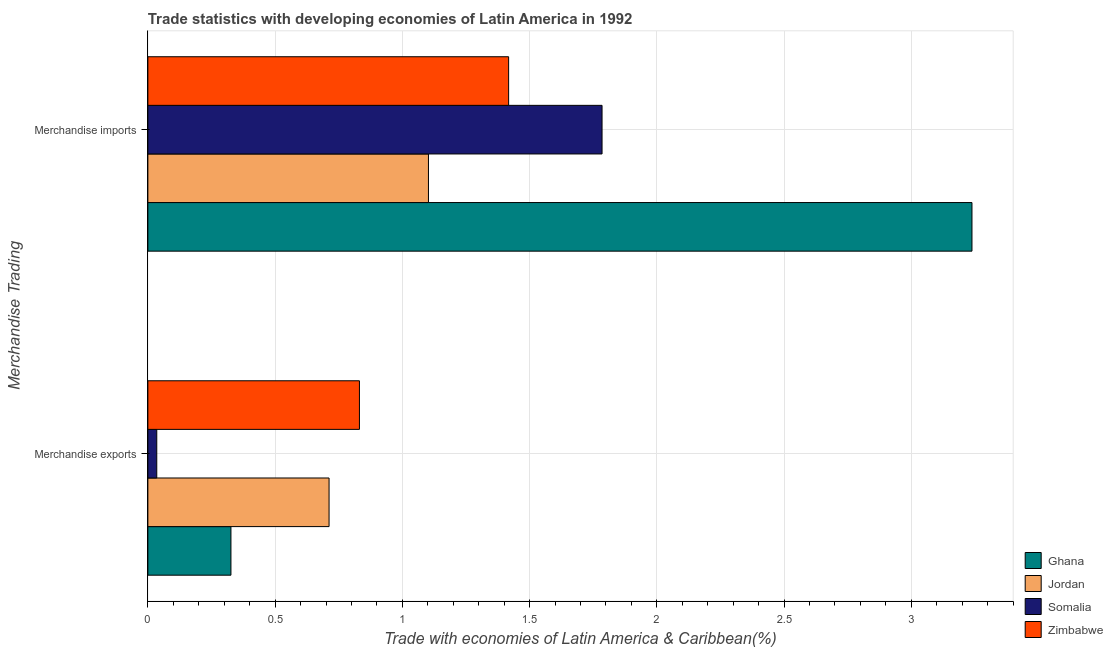Are the number of bars on each tick of the Y-axis equal?
Make the answer very short. Yes. What is the merchandise exports in Jordan?
Give a very brief answer. 0.71. Across all countries, what is the maximum merchandise imports?
Your answer should be very brief. 3.24. Across all countries, what is the minimum merchandise exports?
Your answer should be compact. 0.03. In which country was the merchandise exports minimum?
Provide a short and direct response. Somalia. What is the total merchandise imports in the graph?
Ensure brevity in your answer.  7.54. What is the difference between the merchandise imports in Zimbabwe and that in Ghana?
Provide a succinct answer. -1.82. What is the difference between the merchandise imports in Somalia and the merchandise exports in Ghana?
Your answer should be very brief. 1.46. What is the average merchandise imports per country?
Give a very brief answer. 1.89. What is the difference between the merchandise imports and merchandise exports in Jordan?
Give a very brief answer. 0.39. What is the ratio of the merchandise imports in Jordan to that in Zimbabwe?
Your answer should be very brief. 0.78. Is the merchandise imports in Zimbabwe less than that in Somalia?
Your answer should be very brief. Yes. In how many countries, is the merchandise imports greater than the average merchandise imports taken over all countries?
Make the answer very short. 1. What does the 2nd bar from the top in Merchandise imports represents?
Give a very brief answer. Somalia. What does the 3rd bar from the bottom in Merchandise exports represents?
Your response must be concise. Somalia. How many bars are there?
Provide a succinct answer. 8. How many countries are there in the graph?
Your response must be concise. 4. What is the difference between two consecutive major ticks on the X-axis?
Keep it short and to the point. 0.5. Does the graph contain any zero values?
Give a very brief answer. No. How many legend labels are there?
Make the answer very short. 4. What is the title of the graph?
Your response must be concise. Trade statistics with developing economies of Latin America in 1992. Does "Barbados" appear as one of the legend labels in the graph?
Your answer should be compact. No. What is the label or title of the X-axis?
Make the answer very short. Trade with economies of Latin America & Caribbean(%). What is the label or title of the Y-axis?
Your response must be concise. Merchandise Trading. What is the Trade with economies of Latin America & Caribbean(%) of Ghana in Merchandise exports?
Your answer should be compact. 0.33. What is the Trade with economies of Latin America & Caribbean(%) in Jordan in Merchandise exports?
Provide a succinct answer. 0.71. What is the Trade with economies of Latin America & Caribbean(%) in Somalia in Merchandise exports?
Give a very brief answer. 0.03. What is the Trade with economies of Latin America & Caribbean(%) of Zimbabwe in Merchandise exports?
Your answer should be compact. 0.83. What is the Trade with economies of Latin America & Caribbean(%) of Ghana in Merchandise imports?
Ensure brevity in your answer.  3.24. What is the Trade with economies of Latin America & Caribbean(%) in Jordan in Merchandise imports?
Make the answer very short. 1.1. What is the Trade with economies of Latin America & Caribbean(%) in Somalia in Merchandise imports?
Make the answer very short. 1.78. What is the Trade with economies of Latin America & Caribbean(%) in Zimbabwe in Merchandise imports?
Make the answer very short. 1.42. Across all Merchandise Trading, what is the maximum Trade with economies of Latin America & Caribbean(%) in Ghana?
Offer a terse response. 3.24. Across all Merchandise Trading, what is the maximum Trade with economies of Latin America & Caribbean(%) in Jordan?
Provide a succinct answer. 1.1. Across all Merchandise Trading, what is the maximum Trade with economies of Latin America & Caribbean(%) of Somalia?
Offer a very short reply. 1.78. Across all Merchandise Trading, what is the maximum Trade with economies of Latin America & Caribbean(%) in Zimbabwe?
Give a very brief answer. 1.42. Across all Merchandise Trading, what is the minimum Trade with economies of Latin America & Caribbean(%) in Ghana?
Provide a short and direct response. 0.33. Across all Merchandise Trading, what is the minimum Trade with economies of Latin America & Caribbean(%) in Jordan?
Give a very brief answer. 0.71. Across all Merchandise Trading, what is the minimum Trade with economies of Latin America & Caribbean(%) of Somalia?
Provide a succinct answer. 0.03. Across all Merchandise Trading, what is the minimum Trade with economies of Latin America & Caribbean(%) in Zimbabwe?
Give a very brief answer. 0.83. What is the total Trade with economies of Latin America & Caribbean(%) in Ghana in the graph?
Provide a short and direct response. 3.56. What is the total Trade with economies of Latin America & Caribbean(%) of Jordan in the graph?
Give a very brief answer. 1.81. What is the total Trade with economies of Latin America & Caribbean(%) in Somalia in the graph?
Your answer should be very brief. 1.82. What is the total Trade with economies of Latin America & Caribbean(%) in Zimbabwe in the graph?
Give a very brief answer. 2.25. What is the difference between the Trade with economies of Latin America & Caribbean(%) of Ghana in Merchandise exports and that in Merchandise imports?
Your answer should be very brief. -2.91. What is the difference between the Trade with economies of Latin America & Caribbean(%) in Jordan in Merchandise exports and that in Merchandise imports?
Provide a succinct answer. -0.39. What is the difference between the Trade with economies of Latin America & Caribbean(%) in Somalia in Merchandise exports and that in Merchandise imports?
Offer a very short reply. -1.75. What is the difference between the Trade with economies of Latin America & Caribbean(%) of Zimbabwe in Merchandise exports and that in Merchandise imports?
Provide a succinct answer. -0.59. What is the difference between the Trade with economies of Latin America & Caribbean(%) in Ghana in Merchandise exports and the Trade with economies of Latin America & Caribbean(%) in Jordan in Merchandise imports?
Your answer should be compact. -0.78. What is the difference between the Trade with economies of Latin America & Caribbean(%) in Ghana in Merchandise exports and the Trade with economies of Latin America & Caribbean(%) in Somalia in Merchandise imports?
Provide a short and direct response. -1.46. What is the difference between the Trade with economies of Latin America & Caribbean(%) of Ghana in Merchandise exports and the Trade with economies of Latin America & Caribbean(%) of Zimbabwe in Merchandise imports?
Your answer should be very brief. -1.09. What is the difference between the Trade with economies of Latin America & Caribbean(%) in Jordan in Merchandise exports and the Trade with economies of Latin America & Caribbean(%) in Somalia in Merchandise imports?
Provide a succinct answer. -1.07. What is the difference between the Trade with economies of Latin America & Caribbean(%) of Jordan in Merchandise exports and the Trade with economies of Latin America & Caribbean(%) of Zimbabwe in Merchandise imports?
Give a very brief answer. -0.71. What is the difference between the Trade with economies of Latin America & Caribbean(%) of Somalia in Merchandise exports and the Trade with economies of Latin America & Caribbean(%) of Zimbabwe in Merchandise imports?
Your response must be concise. -1.38. What is the average Trade with economies of Latin America & Caribbean(%) in Ghana per Merchandise Trading?
Provide a short and direct response. 1.78. What is the average Trade with economies of Latin America & Caribbean(%) of Jordan per Merchandise Trading?
Provide a short and direct response. 0.91. What is the average Trade with economies of Latin America & Caribbean(%) in Somalia per Merchandise Trading?
Ensure brevity in your answer.  0.91. What is the average Trade with economies of Latin America & Caribbean(%) in Zimbabwe per Merchandise Trading?
Your answer should be very brief. 1.12. What is the difference between the Trade with economies of Latin America & Caribbean(%) of Ghana and Trade with economies of Latin America & Caribbean(%) of Jordan in Merchandise exports?
Make the answer very short. -0.39. What is the difference between the Trade with economies of Latin America & Caribbean(%) in Ghana and Trade with economies of Latin America & Caribbean(%) in Somalia in Merchandise exports?
Offer a very short reply. 0.29. What is the difference between the Trade with economies of Latin America & Caribbean(%) of Ghana and Trade with economies of Latin America & Caribbean(%) of Zimbabwe in Merchandise exports?
Provide a short and direct response. -0.51. What is the difference between the Trade with economies of Latin America & Caribbean(%) in Jordan and Trade with economies of Latin America & Caribbean(%) in Somalia in Merchandise exports?
Your response must be concise. 0.68. What is the difference between the Trade with economies of Latin America & Caribbean(%) of Jordan and Trade with economies of Latin America & Caribbean(%) of Zimbabwe in Merchandise exports?
Ensure brevity in your answer.  -0.12. What is the difference between the Trade with economies of Latin America & Caribbean(%) in Somalia and Trade with economies of Latin America & Caribbean(%) in Zimbabwe in Merchandise exports?
Your response must be concise. -0.8. What is the difference between the Trade with economies of Latin America & Caribbean(%) of Ghana and Trade with economies of Latin America & Caribbean(%) of Jordan in Merchandise imports?
Give a very brief answer. 2.14. What is the difference between the Trade with economies of Latin America & Caribbean(%) in Ghana and Trade with economies of Latin America & Caribbean(%) in Somalia in Merchandise imports?
Your answer should be compact. 1.45. What is the difference between the Trade with economies of Latin America & Caribbean(%) of Ghana and Trade with economies of Latin America & Caribbean(%) of Zimbabwe in Merchandise imports?
Your response must be concise. 1.82. What is the difference between the Trade with economies of Latin America & Caribbean(%) of Jordan and Trade with economies of Latin America & Caribbean(%) of Somalia in Merchandise imports?
Your answer should be very brief. -0.68. What is the difference between the Trade with economies of Latin America & Caribbean(%) in Jordan and Trade with economies of Latin America & Caribbean(%) in Zimbabwe in Merchandise imports?
Ensure brevity in your answer.  -0.32. What is the difference between the Trade with economies of Latin America & Caribbean(%) in Somalia and Trade with economies of Latin America & Caribbean(%) in Zimbabwe in Merchandise imports?
Ensure brevity in your answer.  0.37. What is the ratio of the Trade with economies of Latin America & Caribbean(%) in Ghana in Merchandise exports to that in Merchandise imports?
Your answer should be very brief. 0.1. What is the ratio of the Trade with economies of Latin America & Caribbean(%) in Jordan in Merchandise exports to that in Merchandise imports?
Offer a terse response. 0.65. What is the ratio of the Trade with economies of Latin America & Caribbean(%) of Somalia in Merchandise exports to that in Merchandise imports?
Your response must be concise. 0.02. What is the ratio of the Trade with economies of Latin America & Caribbean(%) in Zimbabwe in Merchandise exports to that in Merchandise imports?
Provide a succinct answer. 0.59. What is the difference between the highest and the second highest Trade with economies of Latin America & Caribbean(%) in Ghana?
Provide a short and direct response. 2.91. What is the difference between the highest and the second highest Trade with economies of Latin America & Caribbean(%) of Jordan?
Provide a succinct answer. 0.39. What is the difference between the highest and the second highest Trade with economies of Latin America & Caribbean(%) in Somalia?
Make the answer very short. 1.75. What is the difference between the highest and the second highest Trade with economies of Latin America & Caribbean(%) of Zimbabwe?
Keep it short and to the point. 0.59. What is the difference between the highest and the lowest Trade with economies of Latin America & Caribbean(%) in Ghana?
Offer a very short reply. 2.91. What is the difference between the highest and the lowest Trade with economies of Latin America & Caribbean(%) in Jordan?
Your answer should be very brief. 0.39. What is the difference between the highest and the lowest Trade with economies of Latin America & Caribbean(%) in Somalia?
Give a very brief answer. 1.75. What is the difference between the highest and the lowest Trade with economies of Latin America & Caribbean(%) in Zimbabwe?
Offer a terse response. 0.59. 